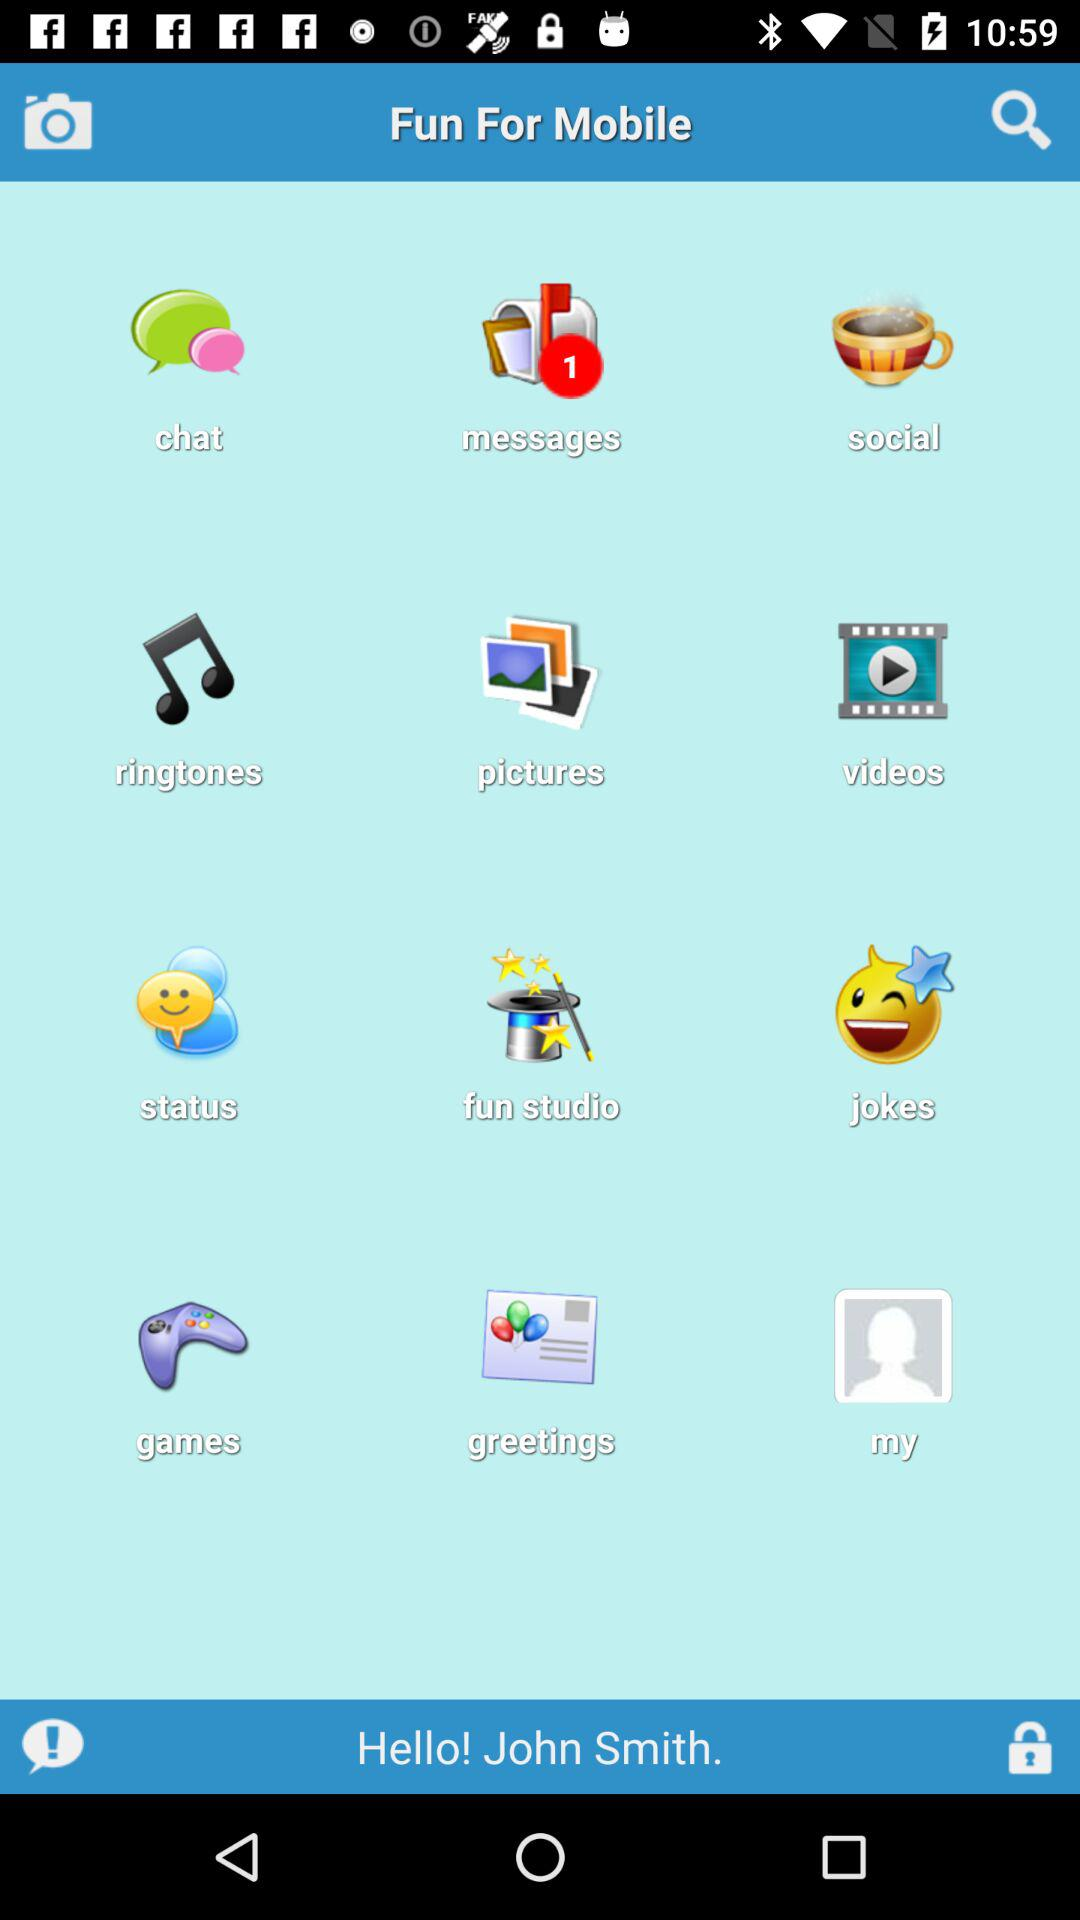Is there any unread message? There is one unread message. 